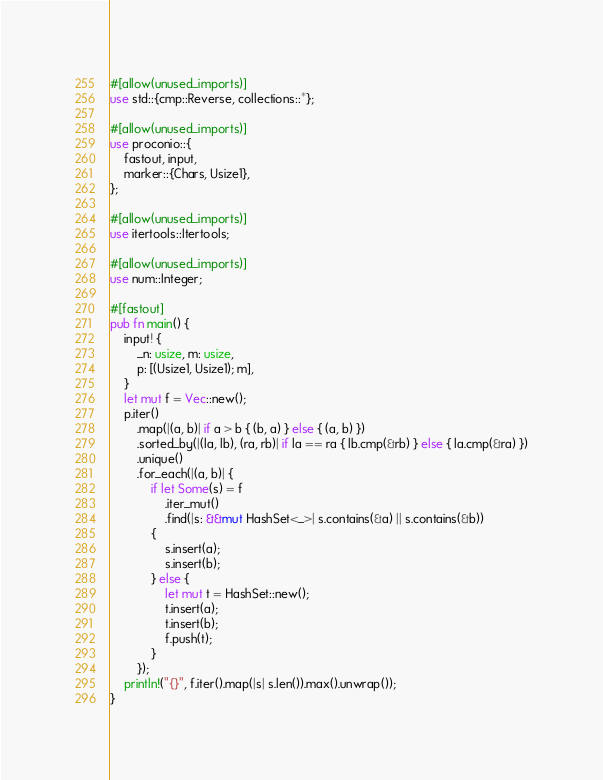Convert code to text. <code><loc_0><loc_0><loc_500><loc_500><_Rust_>#[allow(unused_imports)]
use std::{cmp::Reverse, collections::*};

#[allow(unused_imports)]
use proconio::{
    fastout, input,
    marker::{Chars, Usize1},
};

#[allow(unused_imports)]
use itertools::Itertools;

#[allow(unused_imports)]
use num::Integer;

#[fastout]
pub fn main() {
    input! {
        _n: usize, m: usize,
        p: [(Usize1, Usize1); m],
    }
    let mut f = Vec::new();
    p.iter()
        .map(|(a, b)| if a > b { (b, a) } else { (a, b) })
        .sorted_by(|(la, lb), (ra, rb)| if la == ra { lb.cmp(&rb) } else { la.cmp(&ra) })
        .unique()
        .for_each(|(a, b)| {
            if let Some(s) = f
                .iter_mut()
                .find(|s: &&mut HashSet<_>| s.contains(&a) || s.contains(&b))
            {
                s.insert(a);
                s.insert(b);
            } else {
                let mut t = HashSet::new();
                t.insert(a);
                t.insert(b);
                f.push(t);
            }
        });
    println!("{}", f.iter().map(|s| s.len()).max().unwrap());
}
</code> 